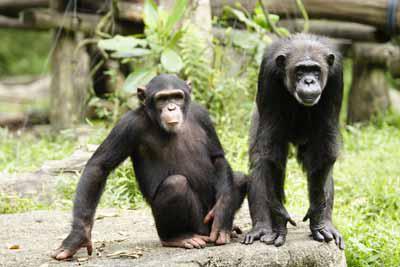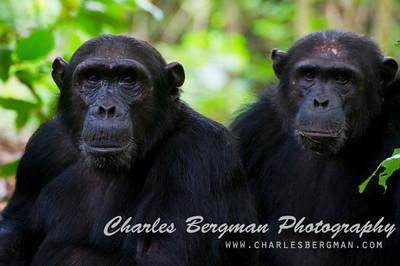The first image is the image on the left, the second image is the image on the right. Considering the images on both sides, is "Each image shows two chimps posed side-by-side, but no chimp has a hand visibly grabbing the other chimp or a wide-open mouth." valid? Answer yes or no. Yes. The first image is the image on the left, the second image is the image on the right. Examine the images to the left and right. Is the description "There is at least one money on the right that is showing its teeth" accurate? Answer yes or no. No. 